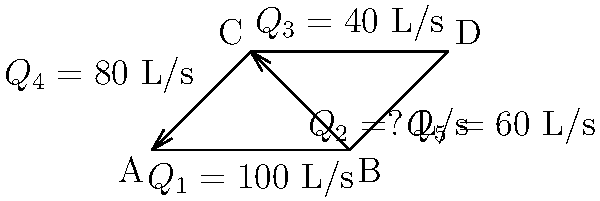As the leader of your engineering empire, you've been tasked with optimizing a complex pipe network system. The diagram shows a network with flow rates in liters per second (L/s). Applying the continuity equation at each junction, determine the unknown flow rate $Q_2$ in L/s. Let's approach this step-by-step using the continuity equation, which states that the sum of inflows equals the sum of outflows at each junction:

1) At junction A:
   Inflow = Outflow
   $Q_1 = Q_4$
   $100 = 80 + Q_2$

2) At junction B:
   Inflow = Outflow
   $Q_1 = Q_2 + Q_5$
   $100 = Q_2 + 60$

3) At junction C:
   Inflow = Outflow
   $Q_2 + Q_4 = Q_3$
   $Q_2 + 80 = 40$

4) From step 3, we can directly solve for $Q_2$:
   $Q_2 = 40 - 80 = -40$

5) We can verify this result using the equations from steps 1 and 2:
   From step 1: $100 = 80 + (-40)$ ✓
   From step 2: $100 = (-40) + 60$ ✓

The negative sign indicates that the flow direction of $Q_2$ is opposite to what was initially assumed in the diagram.
Answer: $Q_2 = -40$ L/s 